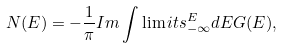<formula> <loc_0><loc_0><loc_500><loc_500>N ( E ) = - \frac { 1 } { \pi } I m \int \lim i t s _ { - \infty } ^ { E } d E G ( E ) ,</formula> 